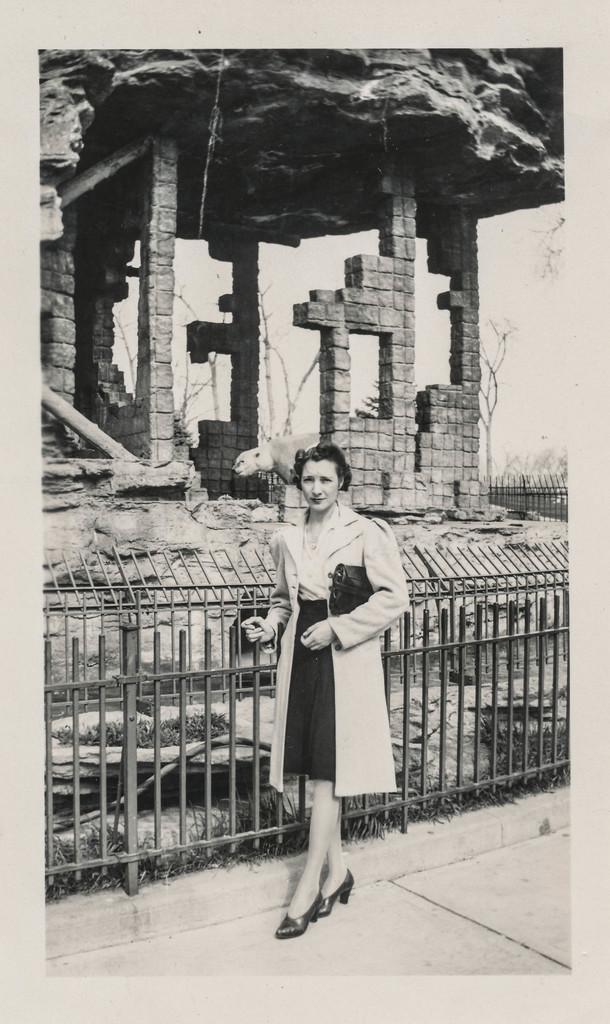How would you summarize this image in a sentence or two? In this image, we can see a person wearing clothes and standing in front of a fence. There is an animal and ancient building in the middle of the image. 